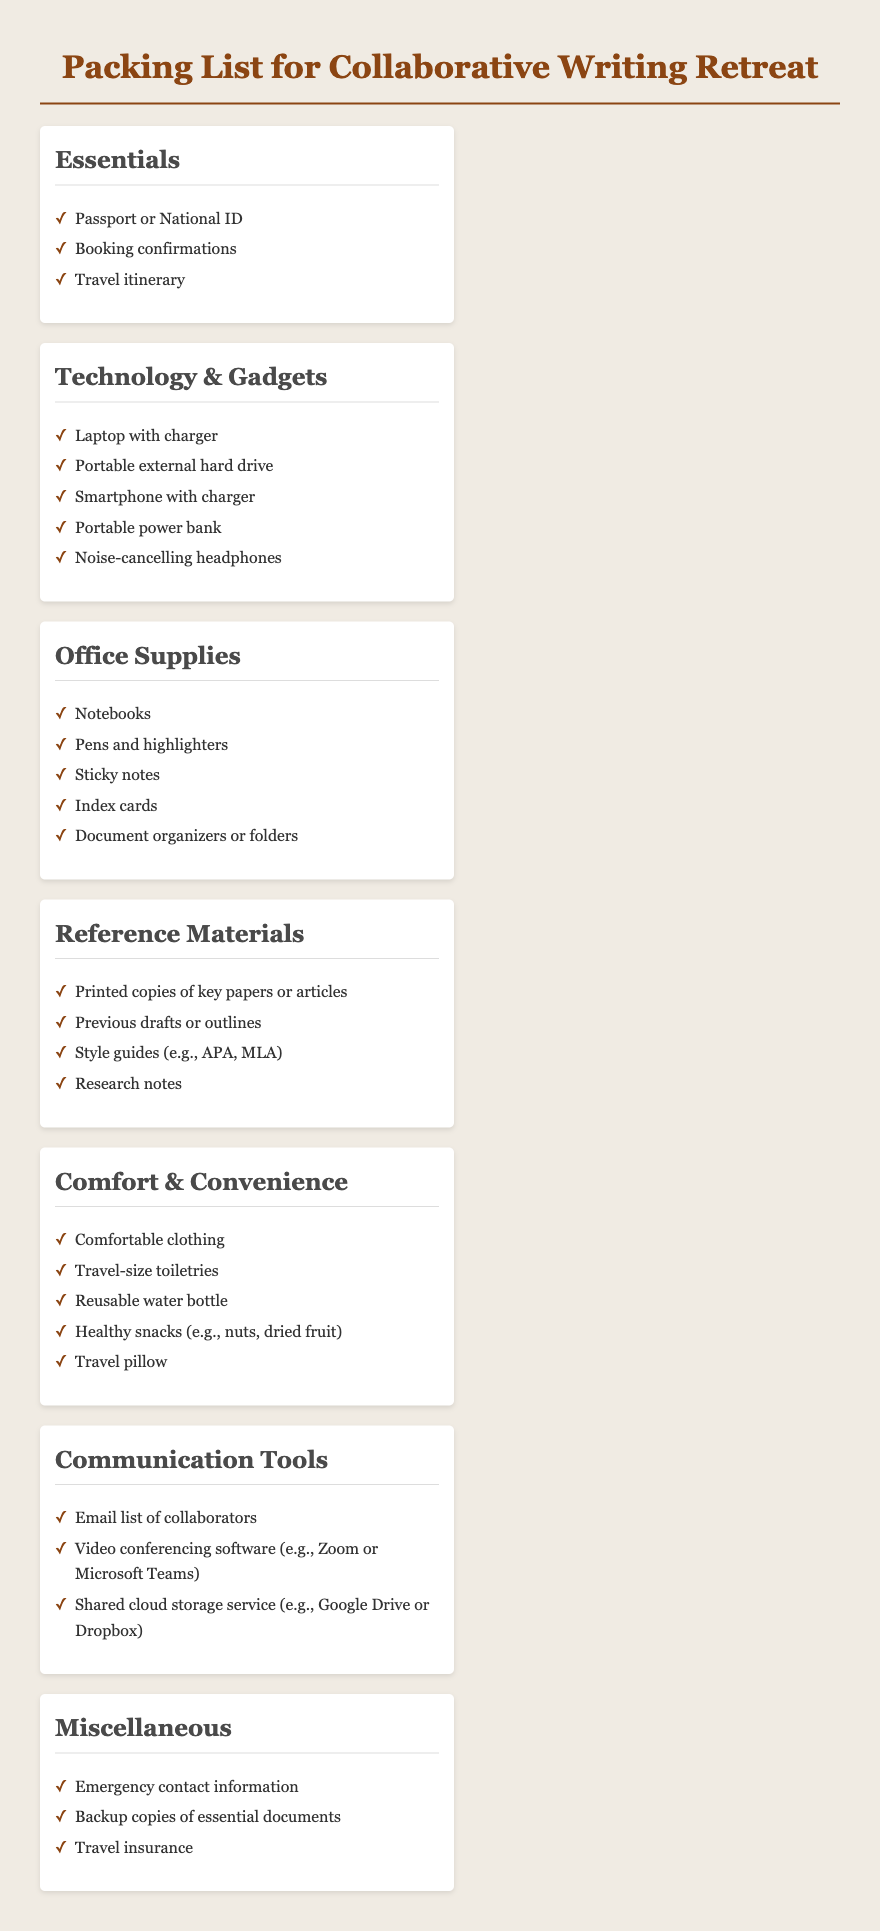what should you bring for technology? The section titled "Technology & Gadgets" lists the items needed for technology.
Answer: Laptop with charger, Portable external hard drive, Smartphone with charger, Portable power bank, Noise-cancelling headphones how many categories are listed in the document? The document has several distinct sections categorized for packing items, which can be counted.
Answer: 7 name one item listed under Comfort & Convenience. The section dedicated to Comfort & Convenience includes various suggested items for comfort.
Answer: Travel-size toiletries which item is included under Reference Materials? The category "Reference Materials" has specific items that should be packed.
Answer: Printed copies of key papers or articles what type of clothing is suggested for the retreat? The item mentioned under Comfort & Convenience indicates what type of clothing to bring.
Answer: Comfortable clothing which category includes communication tools? The document has a section titled "Communication Tools" which addresses specific items required for communication.
Answer: Communication Tools what is one essential document you should have with you? Under the "Essentials" section, various important documents are listed that should be brought along.
Answer: Passport or National ID 